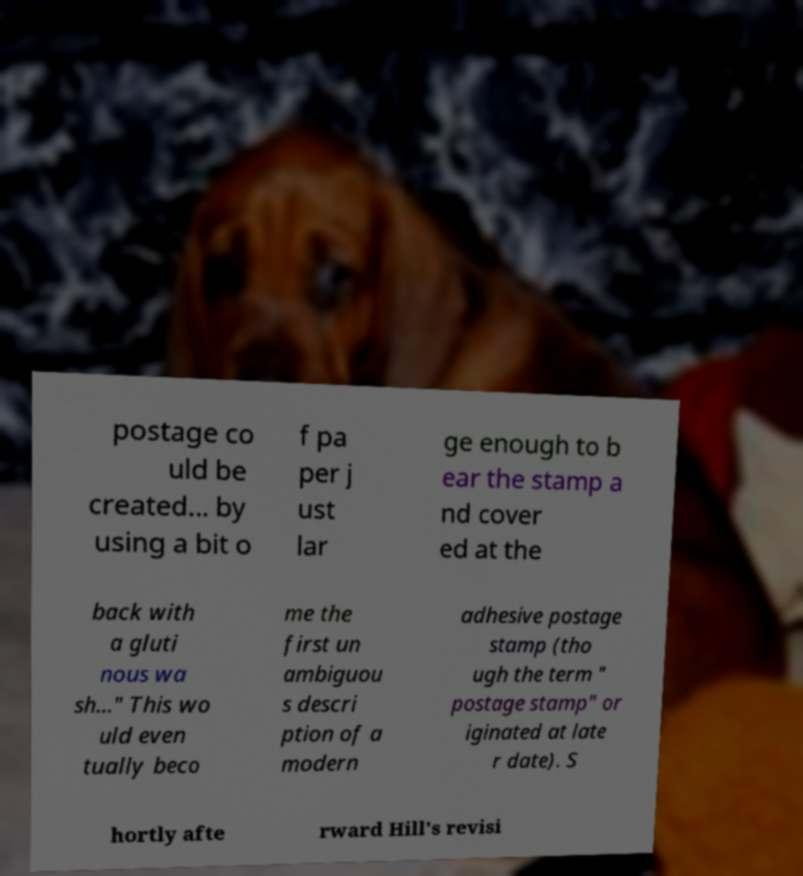Could you assist in decoding the text presented in this image and type it out clearly? postage co uld be created... by using a bit o f pa per j ust lar ge enough to b ear the stamp a nd cover ed at the back with a gluti nous wa sh..." This wo uld even tually beco me the first un ambiguou s descri ption of a modern adhesive postage stamp (tho ugh the term " postage stamp" or iginated at late r date). S hortly afte rward Hill's revisi 